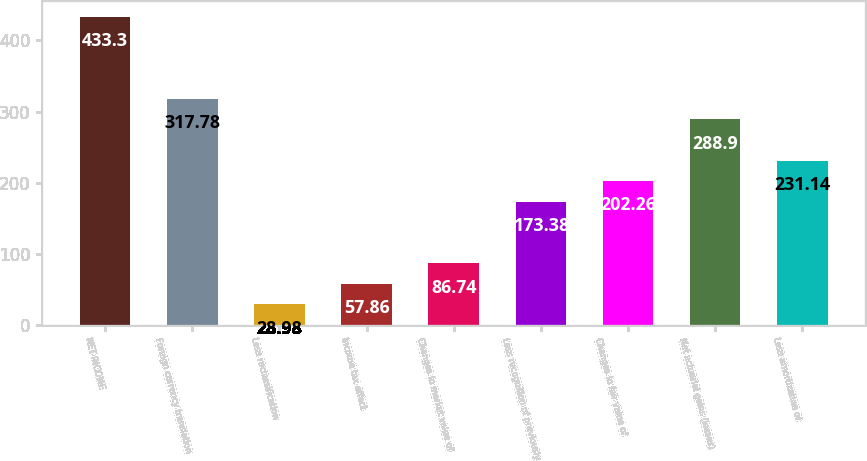<chart> <loc_0><loc_0><loc_500><loc_500><bar_chart><fcel>NET INCOME<fcel>Foreign currency translation<fcel>Less reclassification<fcel>Income tax effect<fcel>Changes in market value of<fcel>Less recognition of previously<fcel>Changes in fair value of<fcel>Net actuarial gains (losses)<fcel>Less amortization of<nl><fcel>433.3<fcel>317.78<fcel>28.98<fcel>57.86<fcel>86.74<fcel>173.38<fcel>202.26<fcel>288.9<fcel>231.14<nl></chart> 